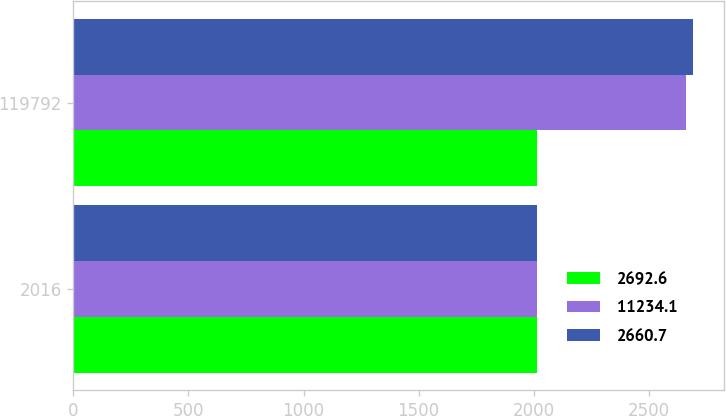Convert chart to OTSL. <chart><loc_0><loc_0><loc_500><loc_500><stacked_bar_chart><ecel><fcel>2016<fcel>119792<nl><fcel>2692.6<fcel>2016<fcel>2016<nl><fcel>11234.1<fcel>2015<fcel>2660.7<nl><fcel>2660.7<fcel>2015<fcel>2692.6<nl></chart> 